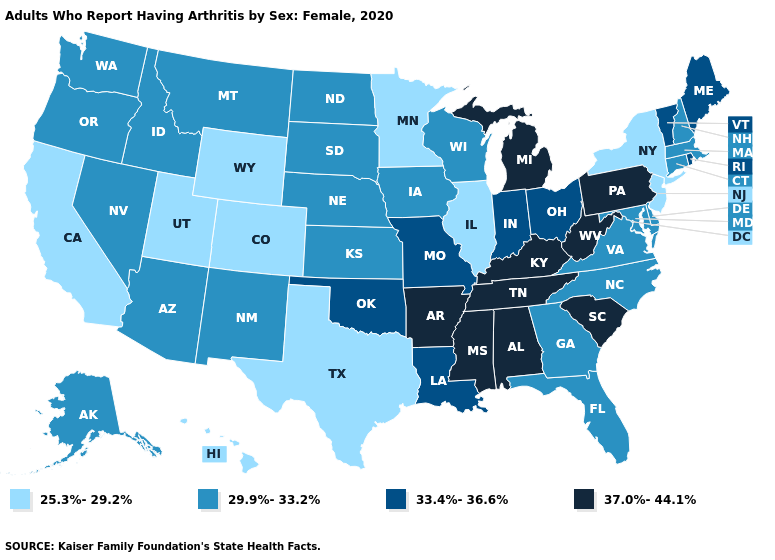What is the highest value in states that border Pennsylvania?
Keep it brief. 37.0%-44.1%. What is the value of Maine?
Quick response, please. 33.4%-36.6%. What is the value of California?
Concise answer only. 25.3%-29.2%. Does Kentucky have the same value as Vermont?
Quick response, please. No. How many symbols are there in the legend?
Concise answer only. 4. What is the highest value in the Northeast ?
Keep it brief. 37.0%-44.1%. Does Mississippi have the highest value in the USA?
Be succinct. Yes. Which states have the highest value in the USA?
Give a very brief answer. Alabama, Arkansas, Kentucky, Michigan, Mississippi, Pennsylvania, South Carolina, Tennessee, West Virginia. Does the map have missing data?
Concise answer only. No. Among the states that border Kansas , does Colorado have the lowest value?
Write a very short answer. Yes. Does South Carolina have a lower value than Arizona?
Keep it brief. No. Does Kentucky have the highest value in the USA?
Be succinct. Yes. How many symbols are there in the legend?
Answer briefly. 4. What is the value of Rhode Island?
Short answer required. 33.4%-36.6%. Does Maryland have a higher value than New Jersey?
Be succinct. Yes. 